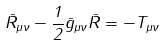<formula> <loc_0><loc_0><loc_500><loc_500>\bar { R } _ { \mu \nu } - \frac { 1 } { 2 } \bar { g } _ { \mu \nu } \bar { R } = - T _ { \mu \nu }</formula> 